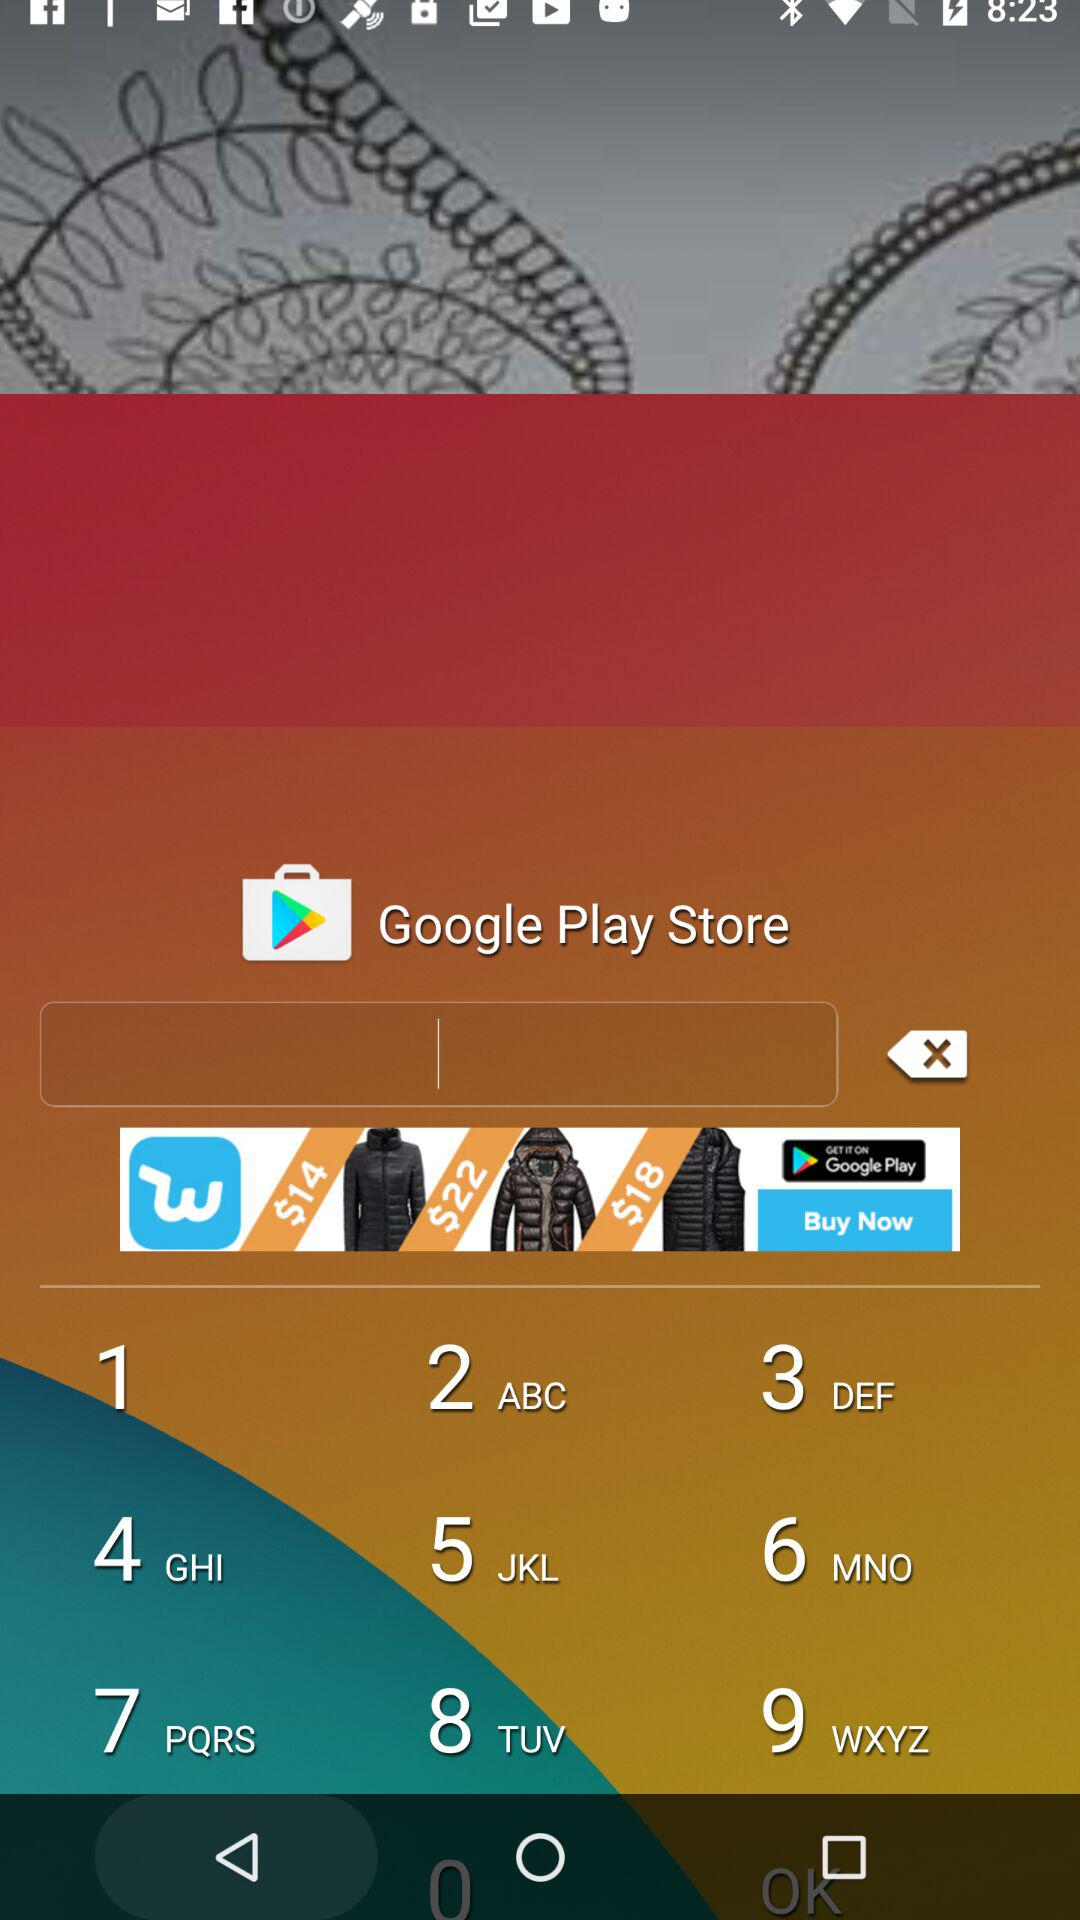What is the name of the application? The name of the application is "Swords Mod Installer". 